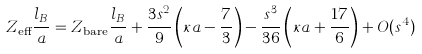Convert formula to latex. <formula><loc_0><loc_0><loc_500><loc_500>Z _ { \text {eff} } \frac { l _ { B } } { a } = Z _ { \text {bare} } \frac { l _ { B } } { a } + \frac { 3 s ^ { 2 } } { 9 } \left ( \kappa a - \frac { 7 } { 3 } \right ) - \frac { s ^ { 3 } } { 3 6 } \left ( \kappa a + \frac { 1 7 } { 6 } \right ) + O ( s ^ { 4 } )</formula> 